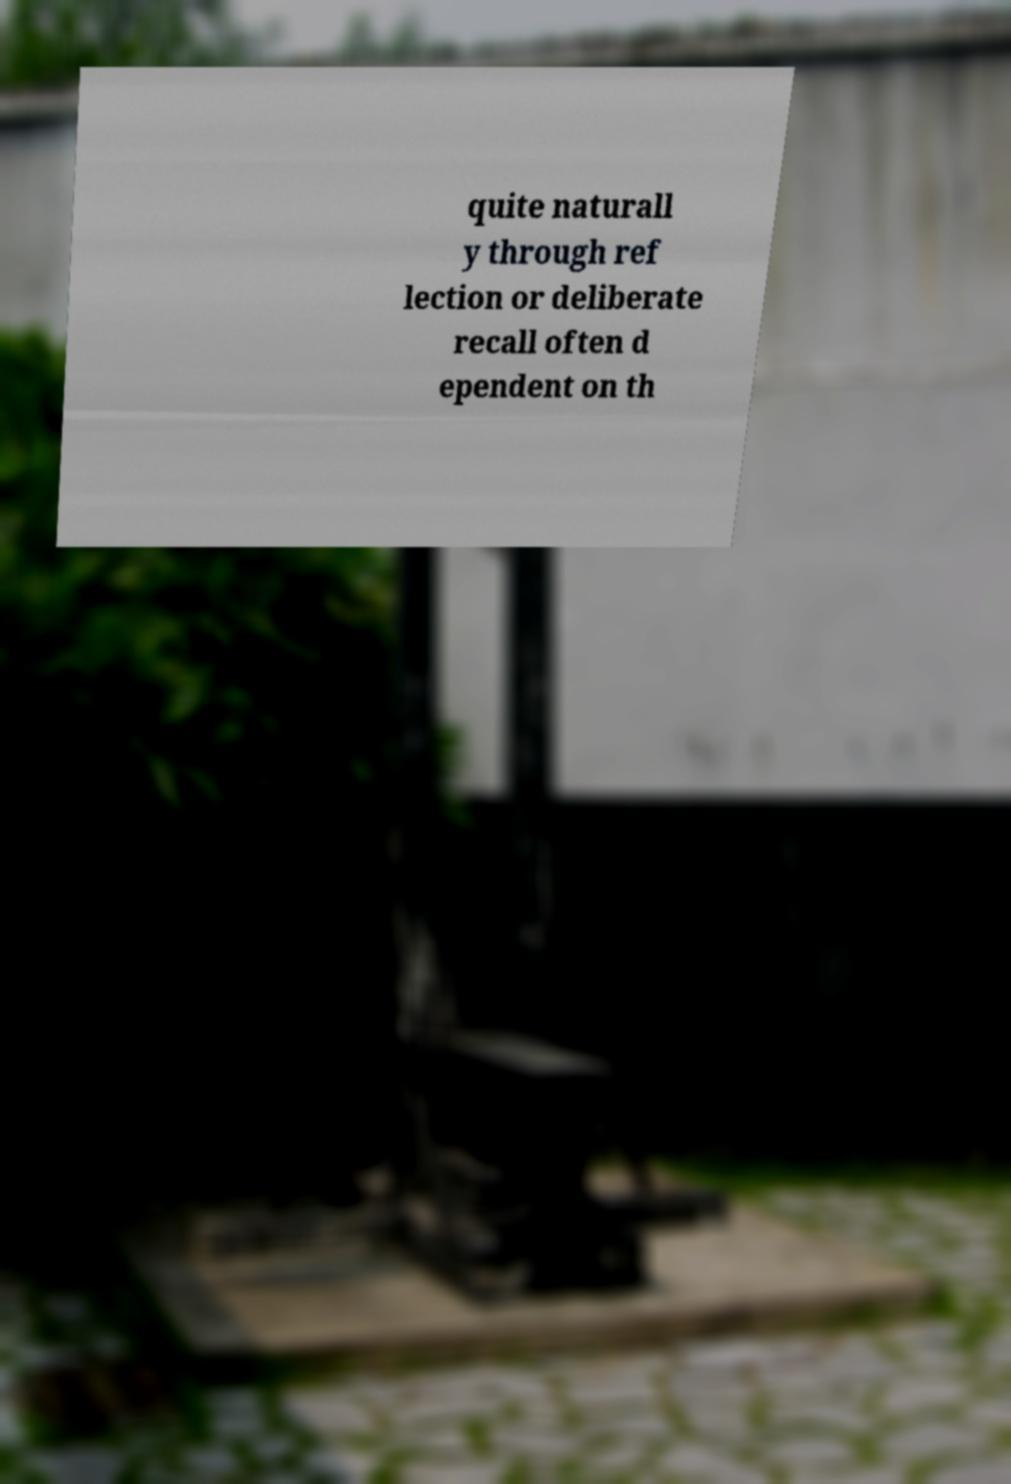I need the written content from this picture converted into text. Can you do that? quite naturall y through ref lection or deliberate recall often d ependent on th 